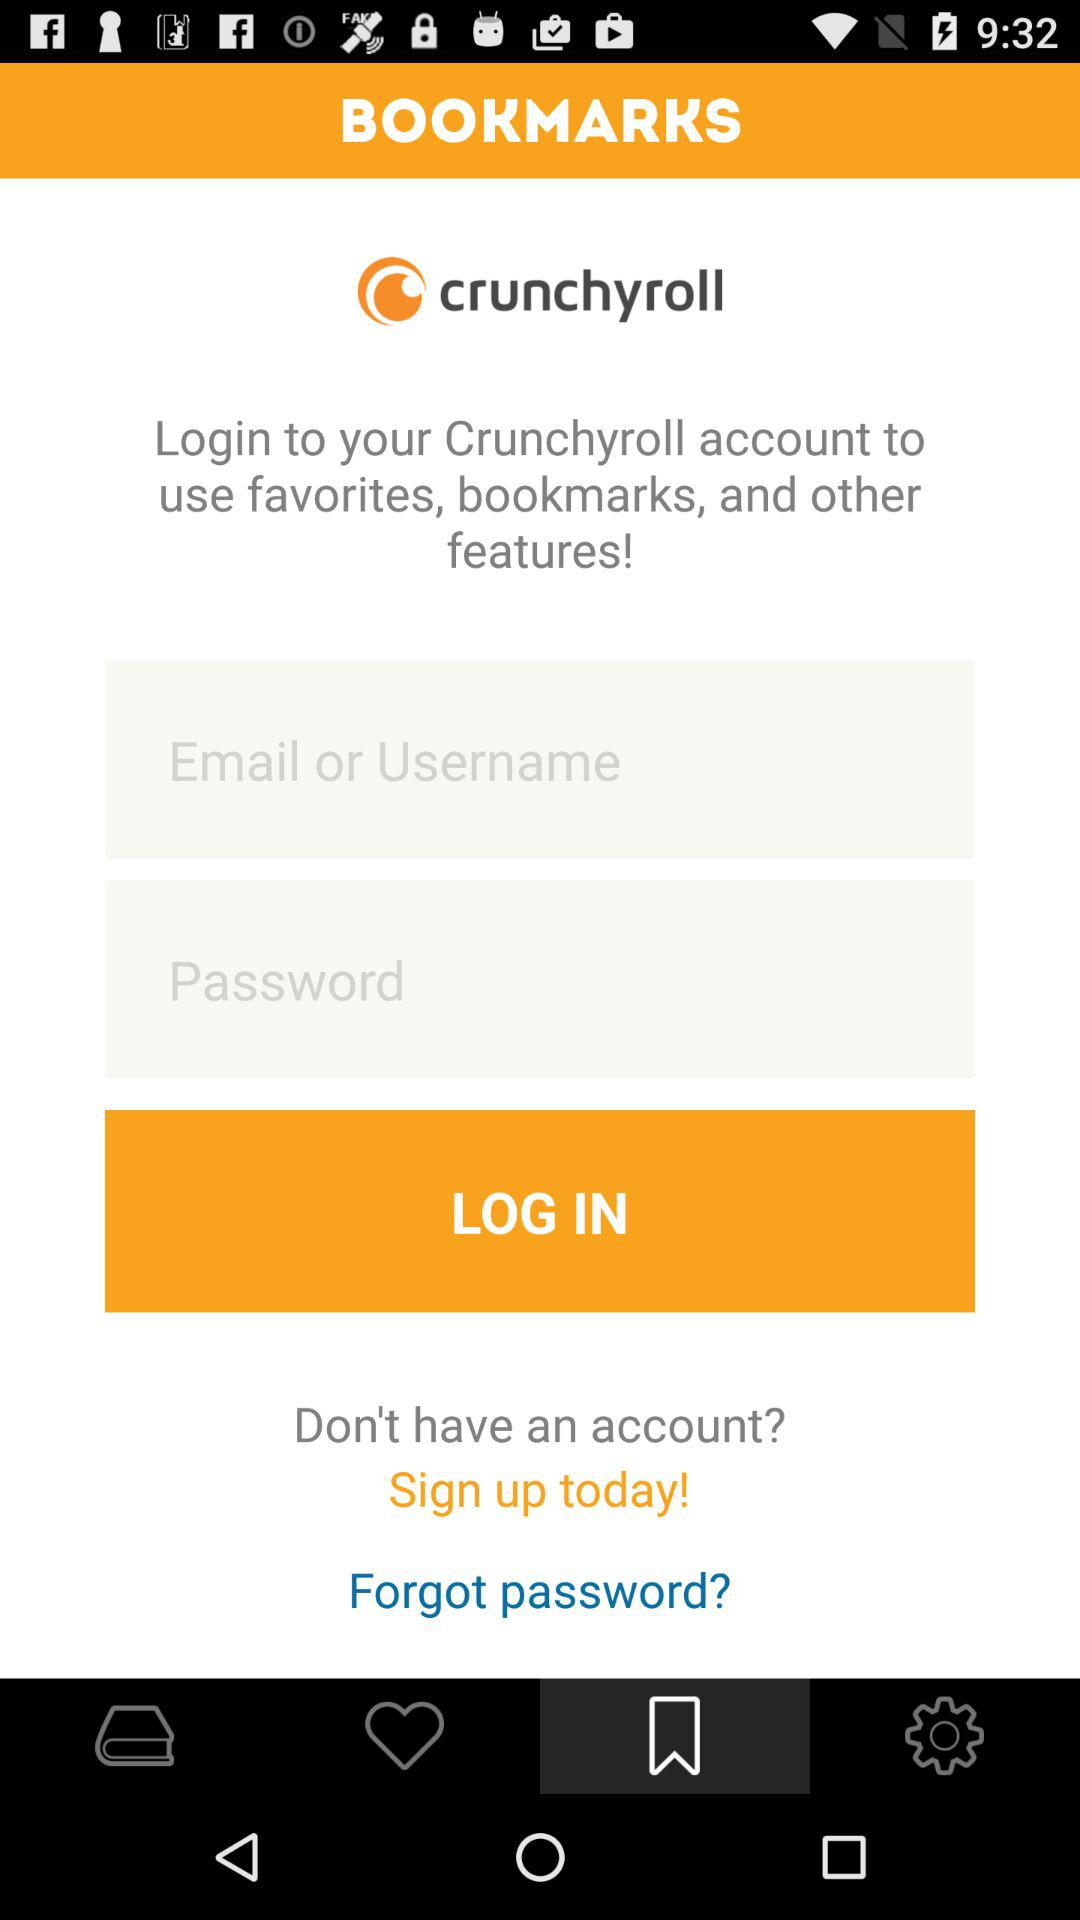Can we reset password?
When the provided information is insufficient, respond with <no answer>. <no answer> 